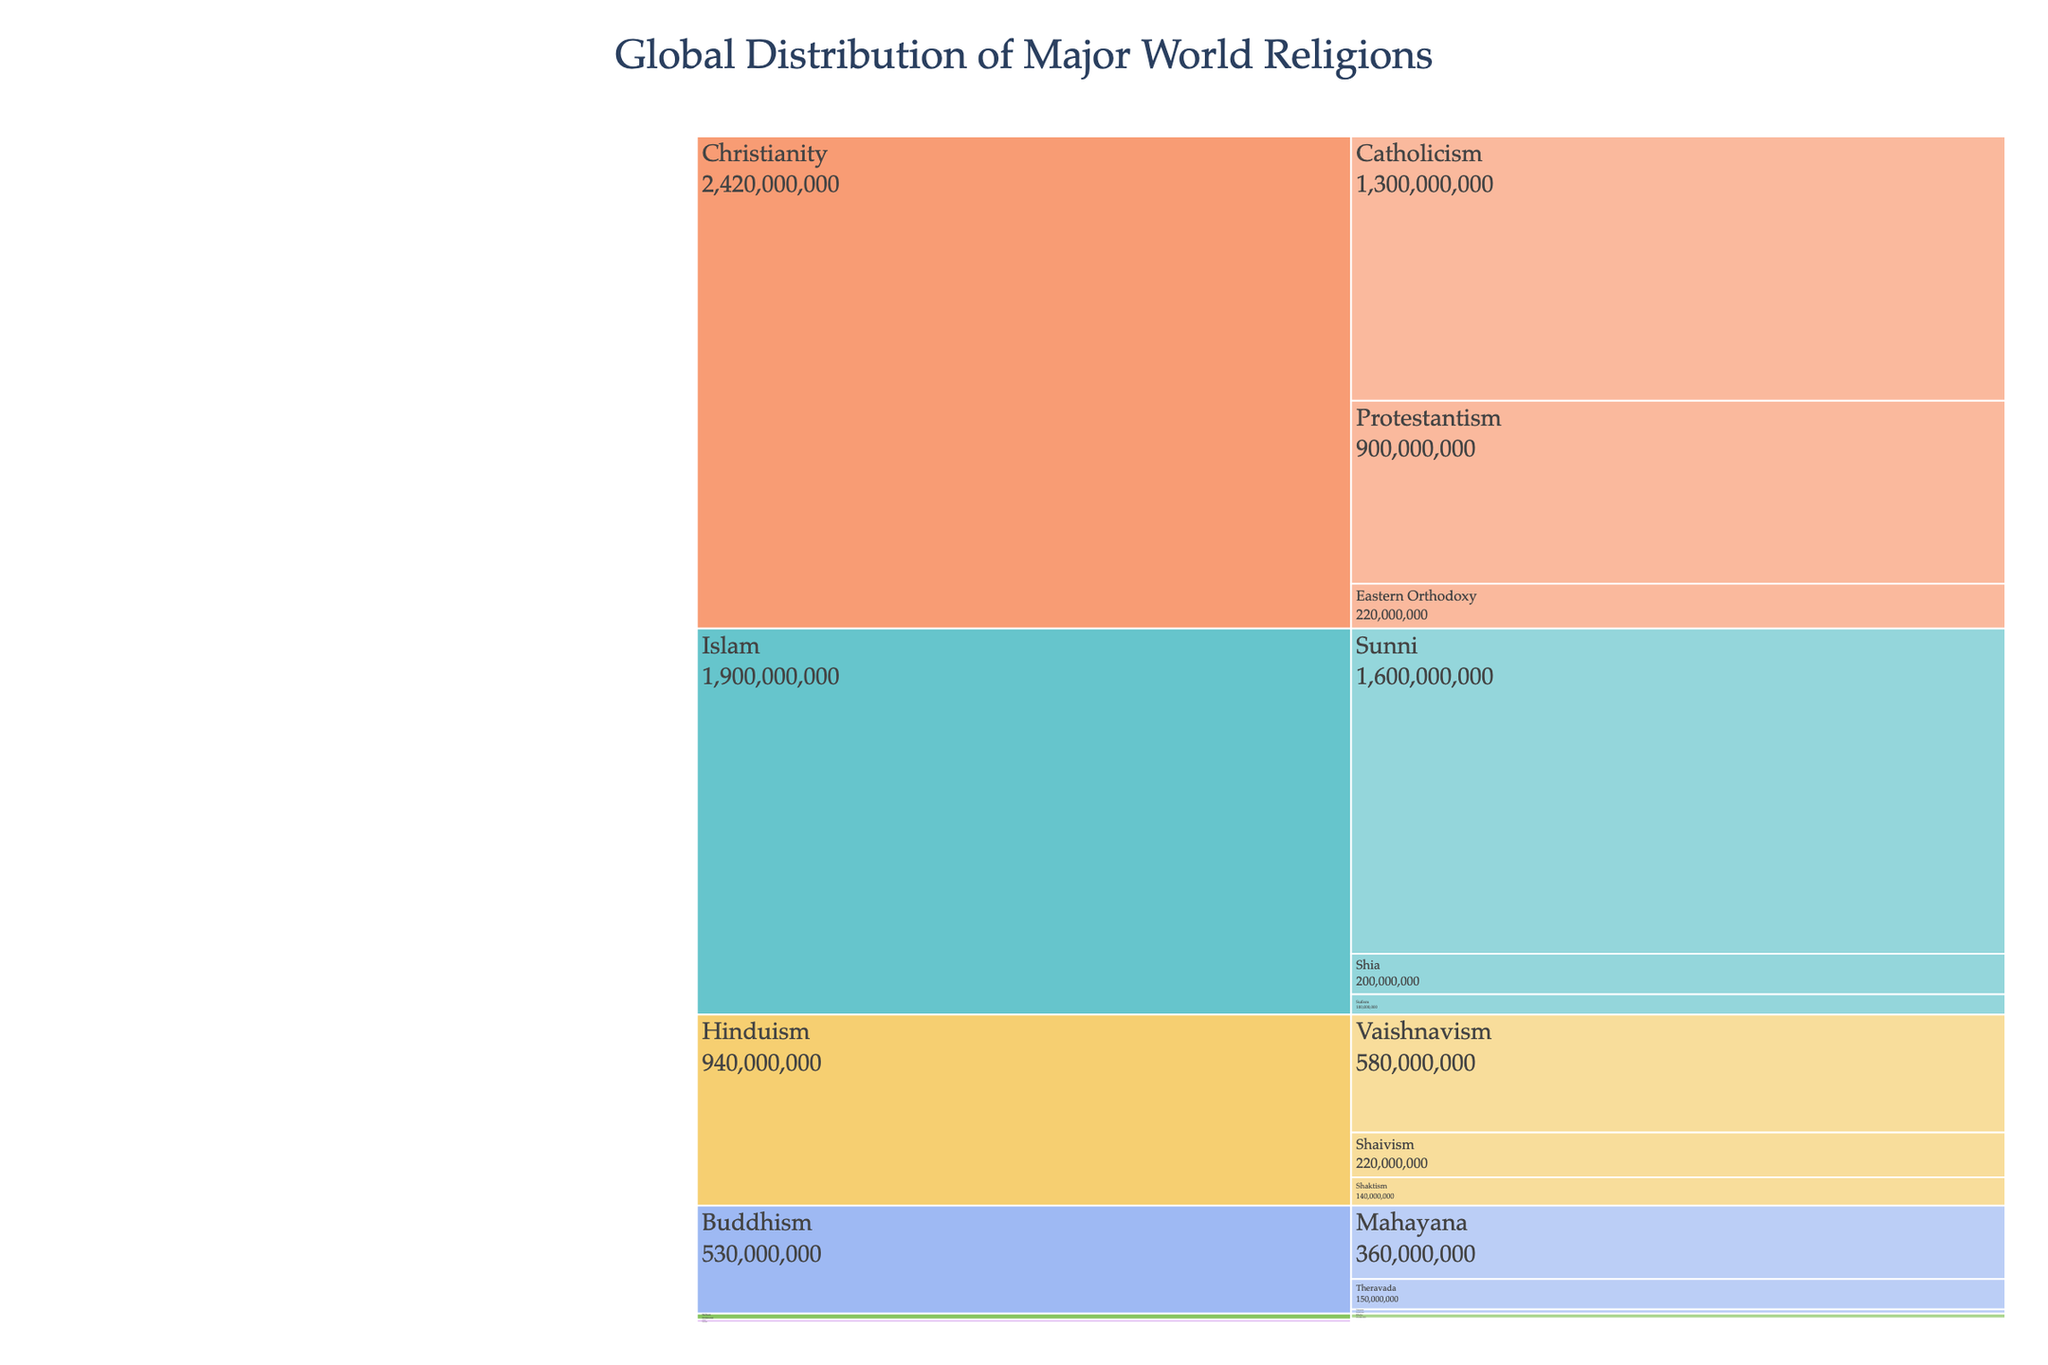What is the title of the chart? The title of the chart is displayed at the top center of the figure and reads "Global Distribution of Major World Religions".
Answer: Global Distribution of Major World Religions Which religion has the highest number of adherents? The icicle chart shows different religions with their respective number of adherents. Christianity is at the top of the hierarchy with 2,300,000,000 followers.
Answer: Christianity How many denominations does Buddhism have according to the chart? The chart breaks down the adherents of each religion into their respective denominations. For Buddhism, there are three denominations: Mahayana, Theravada, and Vajrayana.
Answer: Three What is the total number of followers for all denominations of Hinduism combined? The chart shows the breakdown of Hinduism followers. We can see the numbers 580,000,000 (Vaishnavism), 220,000,000 (Shaivism), and 140,000,000 (Shaktism). Adding these: 580,000,000 + 220,000,000 + 140,000,000 = 940,000,000.
Answer: 940,000,000 How does the number of Sunni followers compare to the total number of Hinduism followers? From the chart, Sunni has 1,600,000,000 followers, while the total number of Hinduism followers is 1,100,000,000. Thus, Sunni followers are greater.
Answer: Sunni followers are more Which denomination within Judaism has the least number of followers? The chart lists three denominations within Judaism. By comparing the numbers, Orthodox has the smallest number of followers with 2,000,000.
Answer: Orthodox What is the difference in the number of followers between Catholicism and Protestantism? According to the chart, Catholicism has 1,300,000,000 followers, and Protestantism has 900,000,000 followers. The difference is 1,300,000,000 - 900,000,000 = 400,000,000.
Answer: 400,000,000 What proportion of Islam's total adherents follows Sufism? There are 1,900,000,000 adherents of Islam, and 100,000,000 of them follow Sufism. So, the proportion is 100,000,000 / 1,900,000,000 = 0.0526, which can be interpreted as approximately 5.26%.
Answer: Approximately 5.26% Compare the total number of followers in Christianity to the combined total of Buddhism and Sikhism. Christianity has 2,300,000,000 followers. Buddhism and Sikhism combined have 500,000,000 + 30,000,000 = 530,000,000 followers. Thus, Christianity has more followers, specifically 2,300,000,000 - 530,000,000 = 1,770,000,000 more.
Answer: Christianity has 1,770,000,000 more followers What is the average number of adherents for the denominations within Judaism? To find the average, we sum the followers of the Jewish denominations: 8,000,000 (Reform) + 3,500,000 (Conservative) + 2,000,000 (Orthodox) = 13,500,000. Then, divide by the number of denominations: 13,500,000 / 3 = 4,500,000.
Answer: 4,500,000 